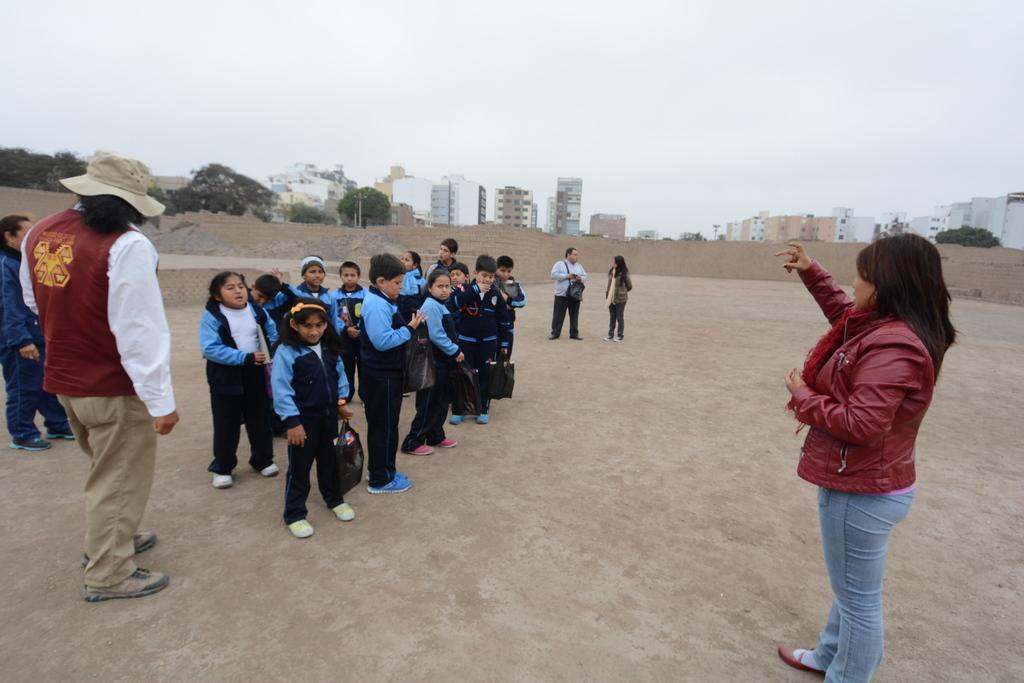What is happening in the foreground of the image? There are people standing on a land in the image. What can be seen in the background of the image? There are buildings, trees, and the sky visible in the background of the image. How many pies are being served by the parent in the image? There is no parent or pies present in the image. What type of loss is being experienced by the people in the image? There is no indication of loss in the image; it simply shows people standing on a land with buildings, trees, and the sky in the background. 